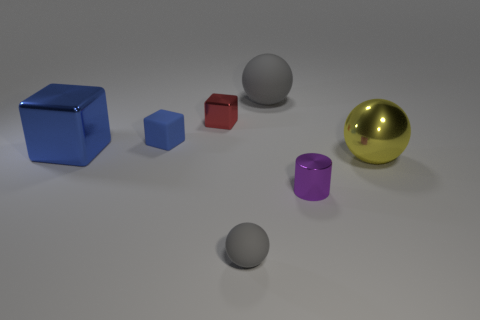If the larger cube and the sphere were to be used in a game, what roles could they play based on their sizes and appearances? Based on their sizes and appearances, the large cube could serve as a weighted puzzle block or a platform for the player to move or stand on, while the golden sphere might be an important collectible item or a key that unlocks new areas or power-ups in the game. 